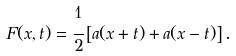<formula> <loc_0><loc_0><loc_500><loc_500>F ( x , t ) = \cfrac { 1 } { 2 } \left [ a ( x + t ) + a ( x - t ) \right ] .</formula> 